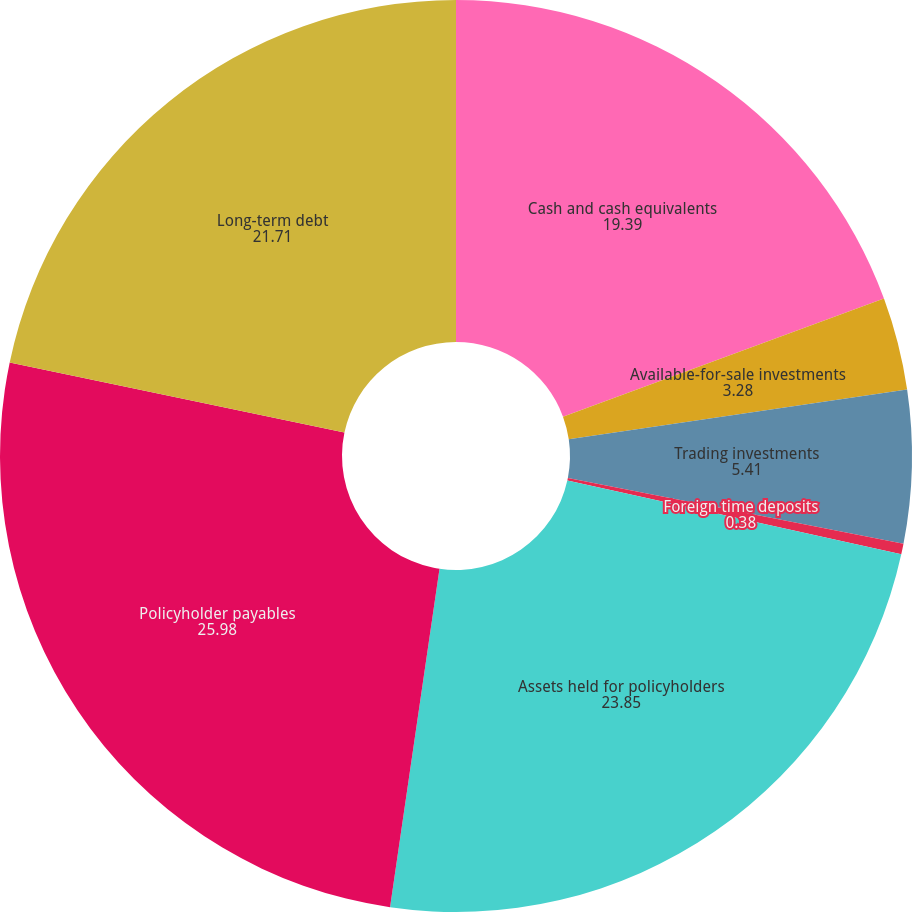Convert chart. <chart><loc_0><loc_0><loc_500><loc_500><pie_chart><fcel>Cash and cash equivalents<fcel>Available-for-sale investments<fcel>Trading investments<fcel>Foreign time deposits<fcel>Assets held for policyholders<fcel>Policyholder payables<fcel>Long-term debt<nl><fcel>19.39%<fcel>3.28%<fcel>5.41%<fcel>0.38%<fcel>23.85%<fcel>25.98%<fcel>21.71%<nl></chart> 